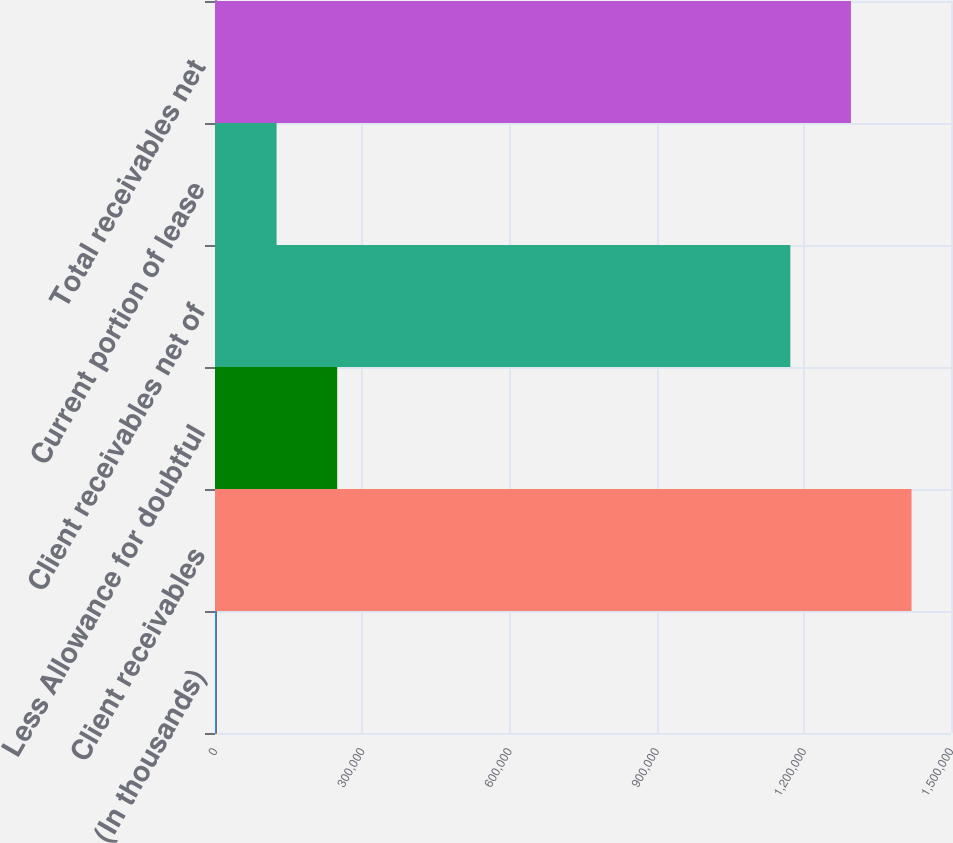Convert chart to OTSL. <chart><loc_0><loc_0><loc_500><loc_500><bar_chart><fcel>(In thousands)<fcel>Client receivables<fcel>Less Allowance for doubtful<fcel>Client receivables net of<fcel>Current portion of lease<fcel>Total receivables net<nl><fcel>2018<fcel>1.41959e+06<fcel>249040<fcel>1.17257e+06<fcel>125529<fcel>1.29608e+06<nl></chart> 